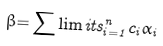Convert formula to latex. <formula><loc_0><loc_0><loc_500><loc_500>\beta \mathcal { = } \sum \lim i t s _ { i = 1 } ^ { n } c _ { i } \alpha _ { i }</formula> 